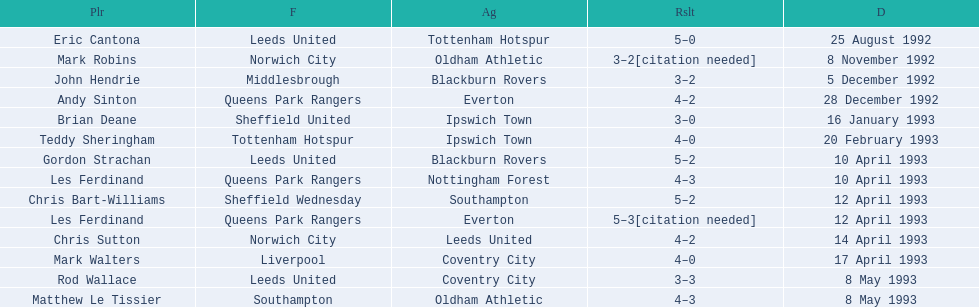Who are all the players? Eric Cantona, Mark Robins, John Hendrie, Andy Sinton, Brian Deane, Teddy Sheringham, Gordon Strachan, Les Ferdinand, Chris Bart-Williams, Les Ferdinand, Chris Sutton, Mark Walters, Rod Wallace, Matthew Le Tissier. What were their results? 5–0, 3–2[citation needed], 3–2, 4–2, 3–0, 4–0, 5–2, 4–3, 5–2, 5–3[citation needed], 4–2, 4–0, 3–3, 4–3. Which player tied with mark robins? John Hendrie. 